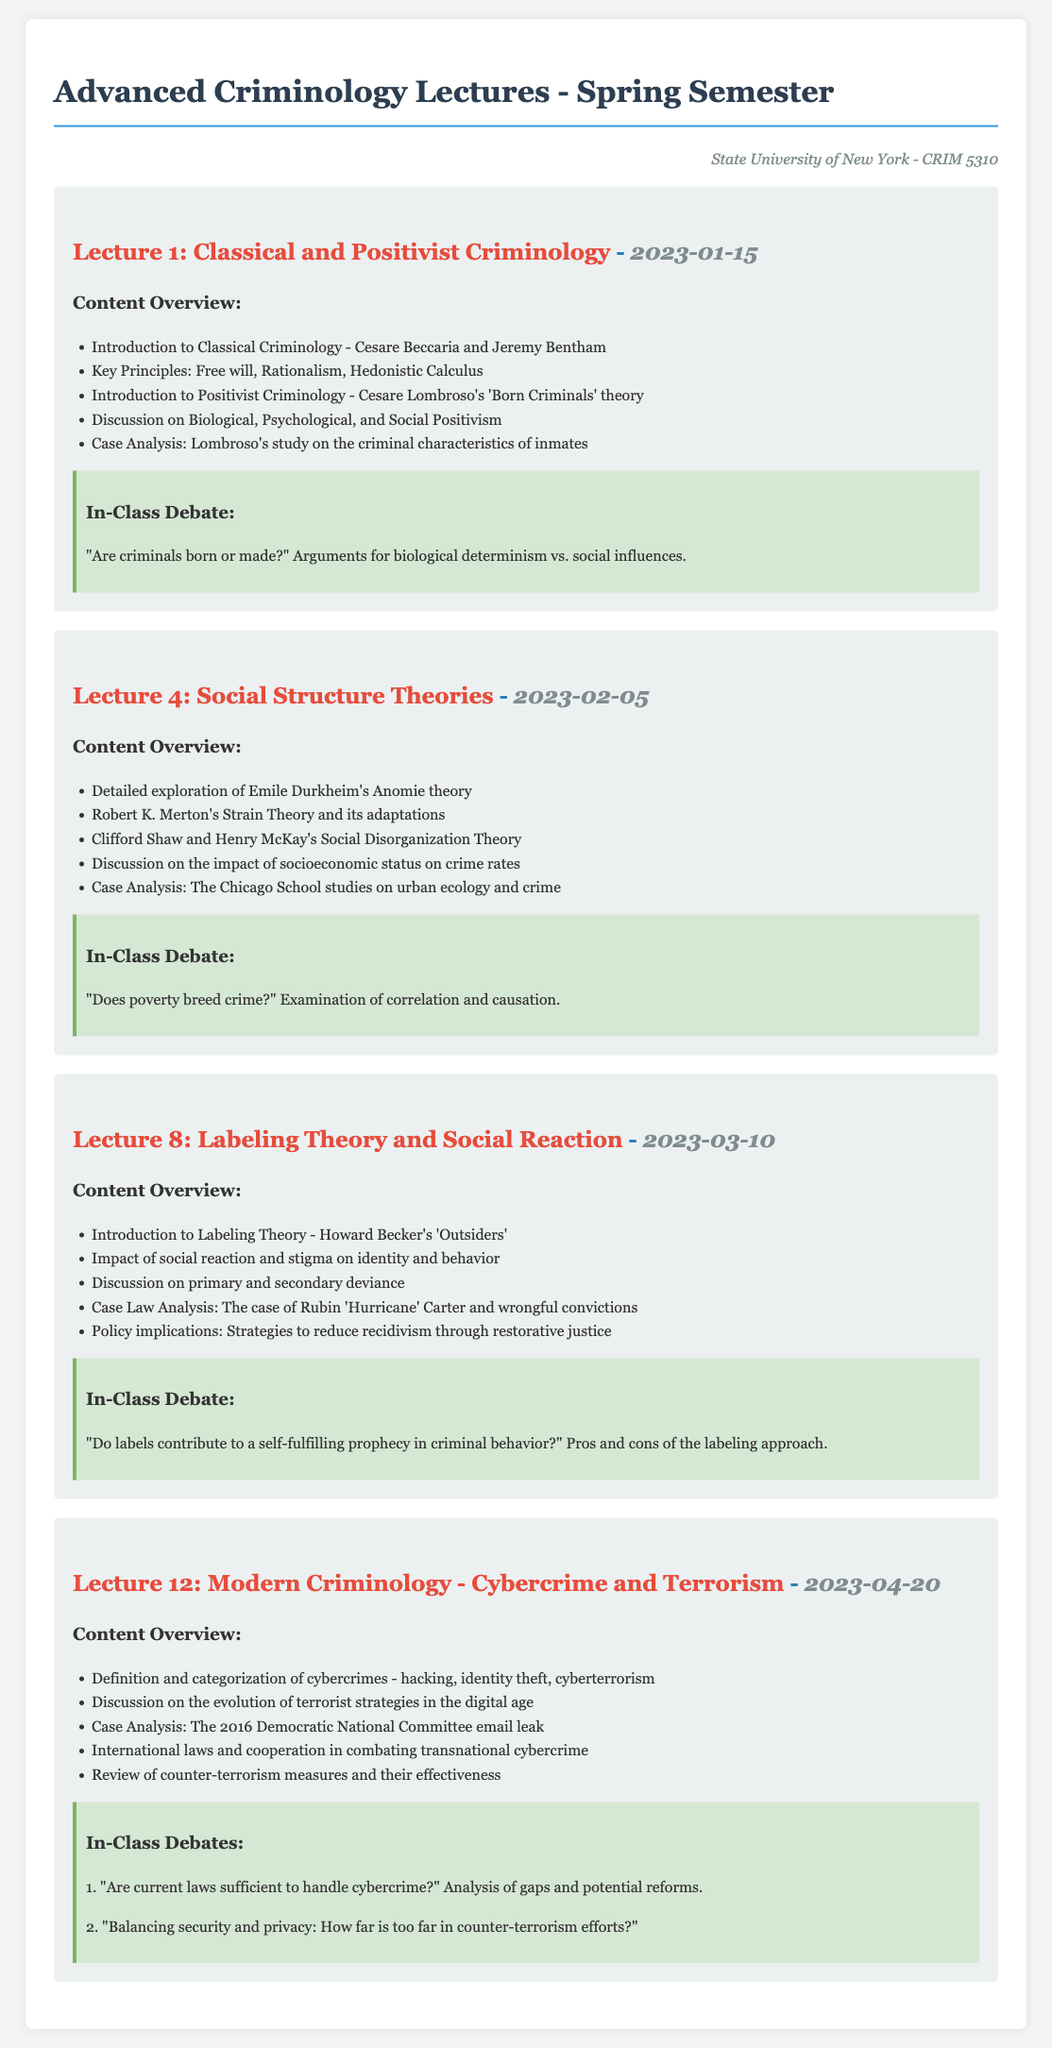What is the title of Lecture 1? The title of Lecture 1 is given in the document.
Answer: Classical and Positivist Criminology Who presented the concept of Labeling Theory? The document mentions Howard Becker in connection with Labeling Theory.
Answer: Howard Becker What date was Lecture 4 held? The date for Lecture 4 is specified in the document.
Answer: 2023-02-05 Which theory discusses socioeconomic status and crime rates? This theory is explicitly stated in the content overview of Lecture 4.
Answer: Social Structure Theories What is the primary focus of Lecture 12? The content overview of Lecture 12 indicates it focuses on a specific type of crime.
Answer: Cybercrime and Terrorism When did the in-class debate regarding "Are criminals born or made?" occur? The specific lecture date where this debate happened can be identified.
Answer: 2023-01-15 What case is analyzed in Lecture 8? The document provides the name of a well-known wrongful conviction case discussed in Lecture 8.
Answer: Rubin 'Hurricane' Carter How many in-class debates are mentioned in Lecture 12? The document explicitly lists the number of debates presented in Lecture 12.
Answer: 2 